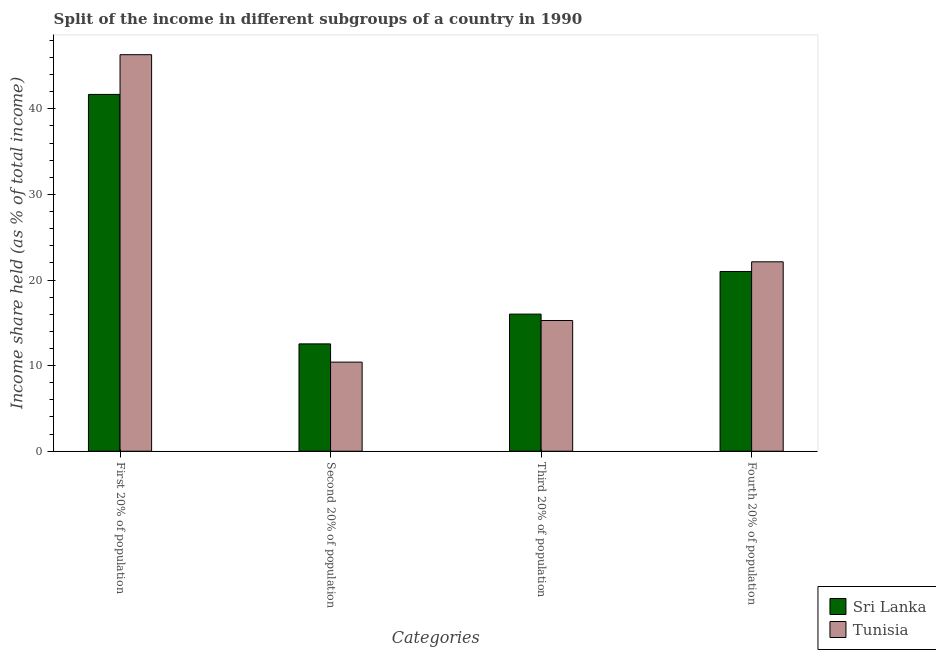How many groups of bars are there?
Provide a short and direct response. 4. Are the number of bars on each tick of the X-axis equal?
Ensure brevity in your answer.  Yes. How many bars are there on the 3rd tick from the left?
Keep it short and to the point. 2. How many bars are there on the 1st tick from the right?
Offer a very short reply. 2. What is the label of the 3rd group of bars from the left?
Make the answer very short. Third 20% of population. What is the share of the income held by fourth 20% of the population in Tunisia?
Make the answer very short. 22.13. Across all countries, what is the maximum share of the income held by second 20% of the population?
Provide a short and direct response. 12.54. Across all countries, what is the minimum share of the income held by fourth 20% of the population?
Ensure brevity in your answer.  21. In which country was the share of the income held by fourth 20% of the population maximum?
Your response must be concise. Tunisia. In which country was the share of the income held by fourth 20% of the population minimum?
Offer a very short reply. Sri Lanka. What is the total share of the income held by third 20% of the population in the graph?
Keep it short and to the point. 31.29. What is the difference between the share of the income held by second 20% of the population in Sri Lanka and the share of the income held by third 20% of the population in Tunisia?
Provide a short and direct response. -2.73. What is the average share of the income held by third 20% of the population per country?
Ensure brevity in your answer.  15.64. What is the difference between the share of the income held by third 20% of the population and share of the income held by second 20% of the population in Tunisia?
Provide a succinct answer. 4.86. In how many countries, is the share of the income held by first 20% of the population greater than 4 %?
Your answer should be compact. 2. What is the ratio of the share of the income held by first 20% of the population in Sri Lanka to that in Tunisia?
Offer a terse response. 0.9. Is the share of the income held by third 20% of the population in Sri Lanka less than that in Tunisia?
Offer a terse response. No. What is the difference between the highest and the second highest share of the income held by third 20% of the population?
Offer a very short reply. 0.75. What is the difference between the highest and the lowest share of the income held by first 20% of the population?
Your response must be concise. 4.64. Is it the case that in every country, the sum of the share of the income held by third 20% of the population and share of the income held by first 20% of the population is greater than the sum of share of the income held by second 20% of the population and share of the income held by fourth 20% of the population?
Your response must be concise. Yes. What does the 1st bar from the left in Fourth 20% of population represents?
Your answer should be very brief. Sri Lanka. What does the 2nd bar from the right in First 20% of population represents?
Provide a short and direct response. Sri Lanka. Is it the case that in every country, the sum of the share of the income held by first 20% of the population and share of the income held by second 20% of the population is greater than the share of the income held by third 20% of the population?
Give a very brief answer. Yes. Are all the bars in the graph horizontal?
Offer a very short reply. No. What is the difference between two consecutive major ticks on the Y-axis?
Keep it short and to the point. 10. Does the graph contain any zero values?
Give a very brief answer. No. Where does the legend appear in the graph?
Your answer should be compact. Bottom right. How many legend labels are there?
Provide a short and direct response. 2. What is the title of the graph?
Give a very brief answer. Split of the income in different subgroups of a country in 1990. What is the label or title of the X-axis?
Make the answer very short. Categories. What is the label or title of the Y-axis?
Give a very brief answer. Income share held (as % of total income). What is the Income share held (as % of total income) in Sri Lanka in First 20% of population?
Your response must be concise. 41.69. What is the Income share held (as % of total income) in Tunisia in First 20% of population?
Give a very brief answer. 46.33. What is the Income share held (as % of total income) in Sri Lanka in Second 20% of population?
Provide a short and direct response. 12.54. What is the Income share held (as % of total income) in Tunisia in Second 20% of population?
Offer a very short reply. 10.41. What is the Income share held (as % of total income) of Sri Lanka in Third 20% of population?
Provide a short and direct response. 16.02. What is the Income share held (as % of total income) of Tunisia in Third 20% of population?
Make the answer very short. 15.27. What is the Income share held (as % of total income) of Tunisia in Fourth 20% of population?
Provide a succinct answer. 22.13. Across all Categories, what is the maximum Income share held (as % of total income) in Sri Lanka?
Your answer should be compact. 41.69. Across all Categories, what is the maximum Income share held (as % of total income) in Tunisia?
Offer a terse response. 46.33. Across all Categories, what is the minimum Income share held (as % of total income) in Sri Lanka?
Make the answer very short. 12.54. Across all Categories, what is the minimum Income share held (as % of total income) in Tunisia?
Keep it short and to the point. 10.41. What is the total Income share held (as % of total income) of Sri Lanka in the graph?
Ensure brevity in your answer.  91.25. What is the total Income share held (as % of total income) of Tunisia in the graph?
Your answer should be compact. 94.14. What is the difference between the Income share held (as % of total income) in Sri Lanka in First 20% of population and that in Second 20% of population?
Provide a succinct answer. 29.15. What is the difference between the Income share held (as % of total income) in Tunisia in First 20% of population and that in Second 20% of population?
Ensure brevity in your answer.  35.92. What is the difference between the Income share held (as % of total income) in Sri Lanka in First 20% of population and that in Third 20% of population?
Keep it short and to the point. 25.67. What is the difference between the Income share held (as % of total income) of Tunisia in First 20% of population and that in Third 20% of population?
Your answer should be compact. 31.06. What is the difference between the Income share held (as % of total income) of Sri Lanka in First 20% of population and that in Fourth 20% of population?
Your answer should be compact. 20.69. What is the difference between the Income share held (as % of total income) of Tunisia in First 20% of population and that in Fourth 20% of population?
Provide a short and direct response. 24.2. What is the difference between the Income share held (as % of total income) in Sri Lanka in Second 20% of population and that in Third 20% of population?
Make the answer very short. -3.48. What is the difference between the Income share held (as % of total income) in Tunisia in Second 20% of population and that in Third 20% of population?
Give a very brief answer. -4.86. What is the difference between the Income share held (as % of total income) in Sri Lanka in Second 20% of population and that in Fourth 20% of population?
Your answer should be compact. -8.46. What is the difference between the Income share held (as % of total income) in Tunisia in Second 20% of population and that in Fourth 20% of population?
Your response must be concise. -11.72. What is the difference between the Income share held (as % of total income) of Sri Lanka in Third 20% of population and that in Fourth 20% of population?
Keep it short and to the point. -4.98. What is the difference between the Income share held (as % of total income) in Tunisia in Third 20% of population and that in Fourth 20% of population?
Keep it short and to the point. -6.86. What is the difference between the Income share held (as % of total income) of Sri Lanka in First 20% of population and the Income share held (as % of total income) of Tunisia in Second 20% of population?
Provide a short and direct response. 31.28. What is the difference between the Income share held (as % of total income) in Sri Lanka in First 20% of population and the Income share held (as % of total income) in Tunisia in Third 20% of population?
Keep it short and to the point. 26.42. What is the difference between the Income share held (as % of total income) in Sri Lanka in First 20% of population and the Income share held (as % of total income) in Tunisia in Fourth 20% of population?
Your response must be concise. 19.56. What is the difference between the Income share held (as % of total income) of Sri Lanka in Second 20% of population and the Income share held (as % of total income) of Tunisia in Third 20% of population?
Your answer should be compact. -2.73. What is the difference between the Income share held (as % of total income) of Sri Lanka in Second 20% of population and the Income share held (as % of total income) of Tunisia in Fourth 20% of population?
Provide a succinct answer. -9.59. What is the difference between the Income share held (as % of total income) of Sri Lanka in Third 20% of population and the Income share held (as % of total income) of Tunisia in Fourth 20% of population?
Offer a terse response. -6.11. What is the average Income share held (as % of total income) in Sri Lanka per Categories?
Give a very brief answer. 22.81. What is the average Income share held (as % of total income) of Tunisia per Categories?
Your answer should be compact. 23.54. What is the difference between the Income share held (as % of total income) of Sri Lanka and Income share held (as % of total income) of Tunisia in First 20% of population?
Provide a short and direct response. -4.64. What is the difference between the Income share held (as % of total income) in Sri Lanka and Income share held (as % of total income) in Tunisia in Second 20% of population?
Provide a succinct answer. 2.13. What is the difference between the Income share held (as % of total income) in Sri Lanka and Income share held (as % of total income) in Tunisia in Fourth 20% of population?
Offer a terse response. -1.13. What is the ratio of the Income share held (as % of total income) in Sri Lanka in First 20% of population to that in Second 20% of population?
Your answer should be very brief. 3.32. What is the ratio of the Income share held (as % of total income) in Tunisia in First 20% of population to that in Second 20% of population?
Your answer should be very brief. 4.45. What is the ratio of the Income share held (as % of total income) of Sri Lanka in First 20% of population to that in Third 20% of population?
Your answer should be very brief. 2.6. What is the ratio of the Income share held (as % of total income) of Tunisia in First 20% of population to that in Third 20% of population?
Your response must be concise. 3.03. What is the ratio of the Income share held (as % of total income) of Sri Lanka in First 20% of population to that in Fourth 20% of population?
Keep it short and to the point. 1.99. What is the ratio of the Income share held (as % of total income) of Tunisia in First 20% of population to that in Fourth 20% of population?
Offer a terse response. 2.09. What is the ratio of the Income share held (as % of total income) of Sri Lanka in Second 20% of population to that in Third 20% of population?
Make the answer very short. 0.78. What is the ratio of the Income share held (as % of total income) of Tunisia in Second 20% of population to that in Third 20% of population?
Provide a succinct answer. 0.68. What is the ratio of the Income share held (as % of total income) of Sri Lanka in Second 20% of population to that in Fourth 20% of population?
Your answer should be compact. 0.6. What is the ratio of the Income share held (as % of total income) in Tunisia in Second 20% of population to that in Fourth 20% of population?
Make the answer very short. 0.47. What is the ratio of the Income share held (as % of total income) of Sri Lanka in Third 20% of population to that in Fourth 20% of population?
Offer a very short reply. 0.76. What is the ratio of the Income share held (as % of total income) of Tunisia in Third 20% of population to that in Fourth 20% of population?
Provide a short and direct response. 0.69. What is the difference between the highest and the second highest Income share held (as % of total income) of Sri Lanka?
Your answer should be very brief. 20.69. What is the difference between the highest and the second highest Income share held (as % of total income) in Tunisia?
Provide a short and direct response. 24.2. What is the difference between the highest and the lowest Income share held (as % of total income) in Sri Lanka?
Provide a short and direct response. 29.15. What is the difference between the highest and the lowest Income share held (as % of total income) in Tunisia?
Keep it short and to the point. 35.92. 